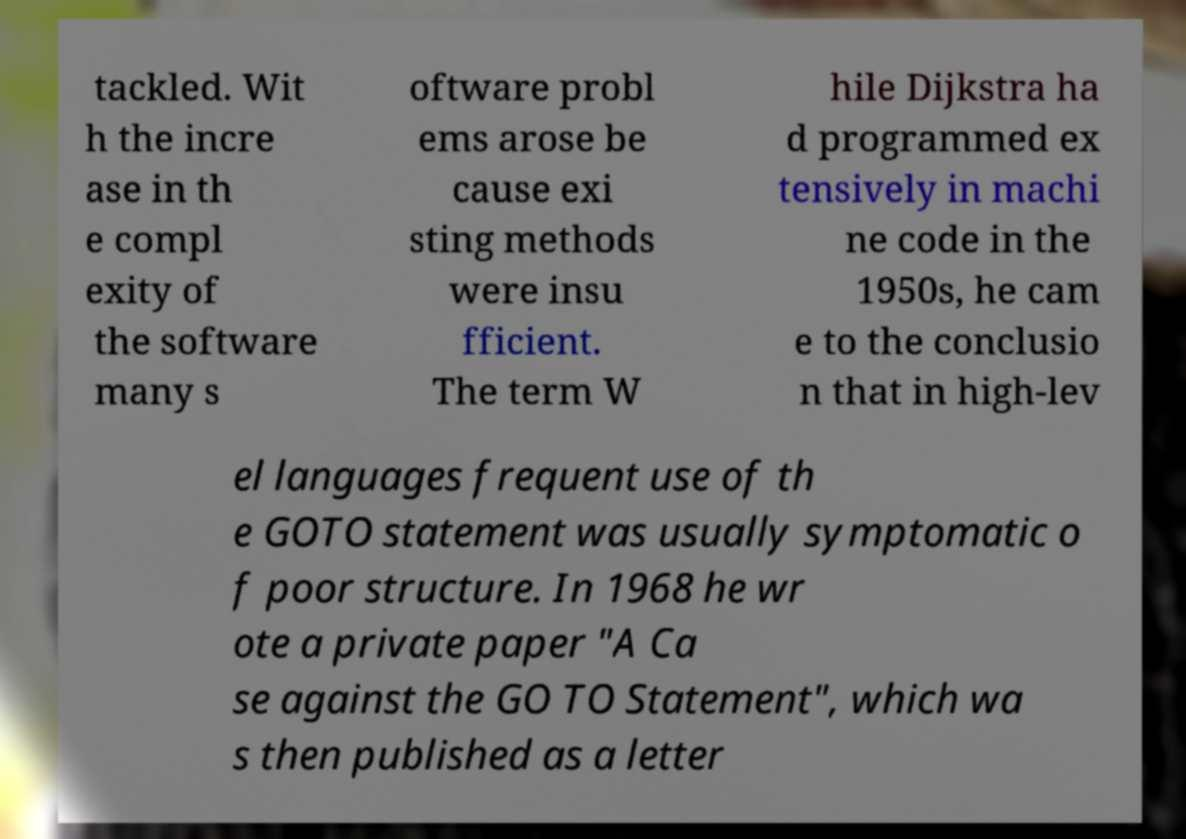Can you accurately transcribe the text from the provided image for me? tackled. Wit h the incre ase in th e compl exity of the software many s oftware probl ems arose be cause exi sting methods were insu fficient. The term W hile Dijkstra ha d programmed ex tensively in machi ne code in the 1950s, he cam e to the conclusio n that in high-lev el languages frequent use of th e GOTO statement was usually symptomatic o f poor structure. In 1968 he wr ote a private paper "A Ca se against the GO TO Statement", which wa s then published as a letter 